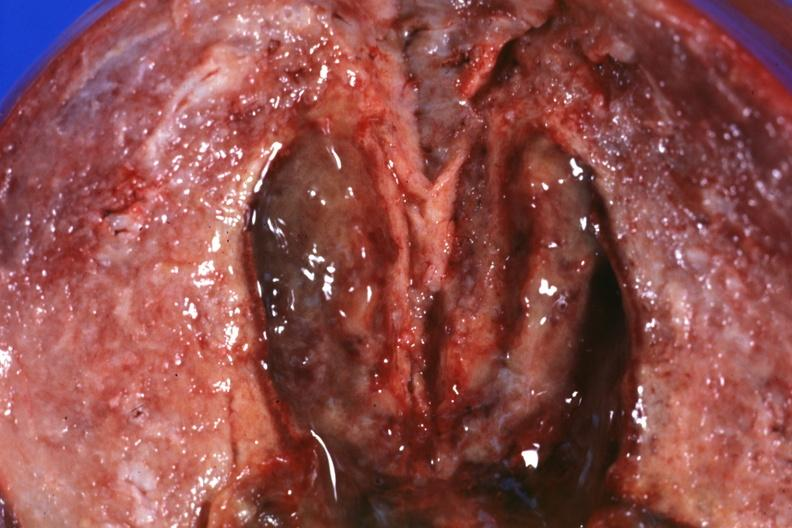s uterus present?
Answer the question using a single word or phrase. Yes 